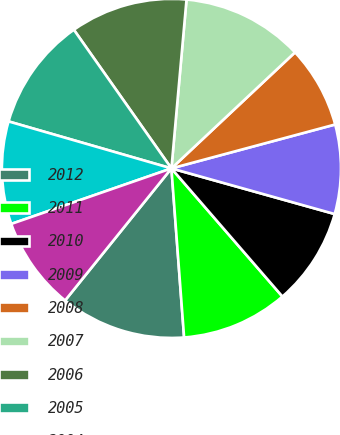<chart> <loc_0><loc_0><loc_500><loc_500><pie_chart><fcel>2012<fcel>2011<fcel>2010<fcel>2009<fcel>2008<fcel>2007<fcel>2006<fcel>2005<fcel>2004<fcel>2003<nl><fcel>11.98%<fcel>10.17%<fcel>9.3%<fcel>8.51%<fcel>7.83%<fcel>11.58%<fcel>11.18%<fcel>10.77%<fcel>9.78%<fcel>8.9%<nl></chart> 